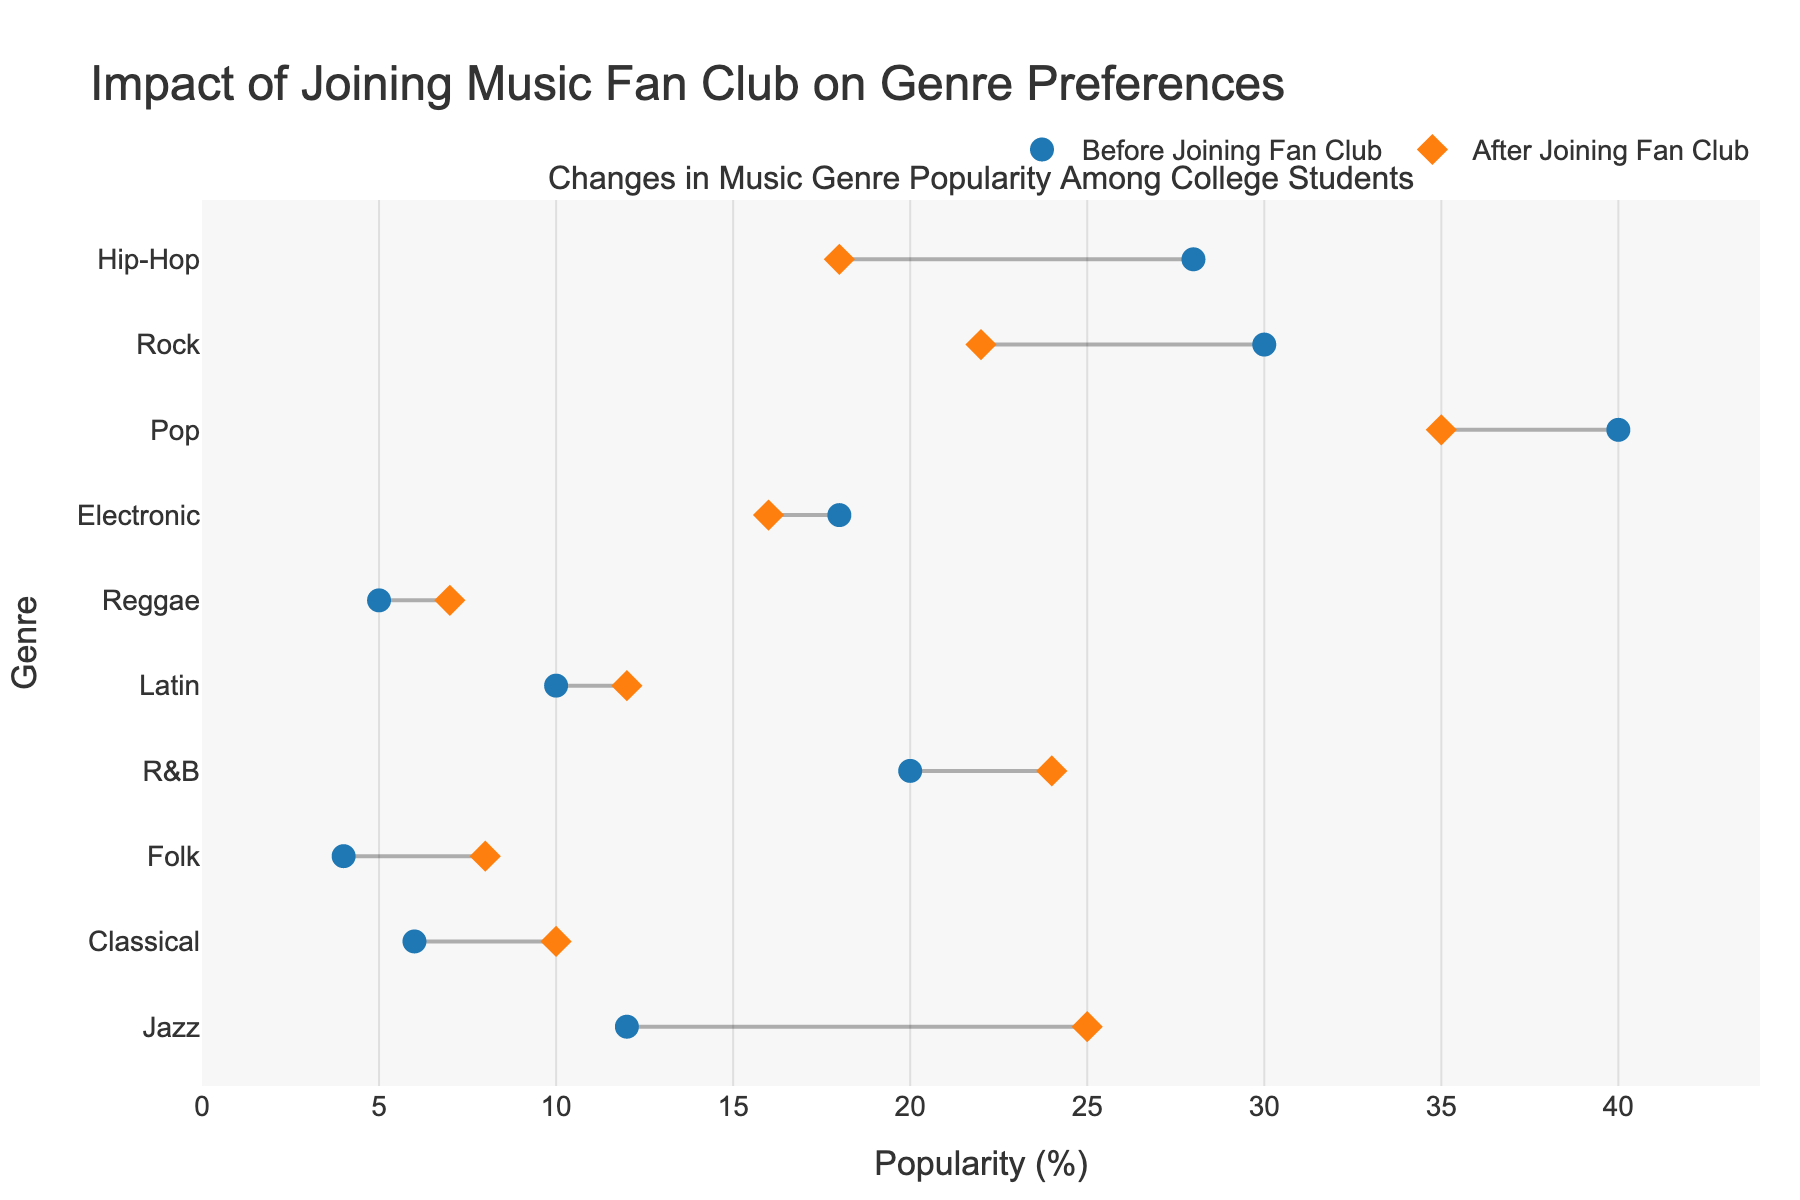What is the title of the figure? The title is clearly displayed at the top of the figure, stating the overall purpose of the plot.
Answer: Impact of Joining Music Fan Club on Genre Preferences What are the colors of the markers for 'Before Joining Fan Club' and 'After Joining Fan Club'? The colors of the markers are visually distinct and are used consistently throughout the plot. The marker for 'Before Joining Fan Club' is blue, and for 'After Joining Fan Club' is orange.
Answer: Blue and Orange Which genre saw the largest increase in popularity after joining the music fan club? The genres are sorted by the difference in popularity, with the largest increase at the top. Jazz has the largest increase, going from 12% to 25%.
Answer: Jazz Which genre saw the largest decrease in popularity after joining the music fan club? By looking at the lengths of the lines, we can identify the largest decrease, which is in Hip-Hop, decreasing from 28% to 18%.
Answer: Hip-Hop What is the overall trend in R&B genre popularity before and after joining the music fan club? The positions of the markers for R&B indicate an increase because the marker for 'After Joining Fan Club' is further right than the marker for 'Before Joining Fan Club’.
Answer: Increase How many genres increased in popularity after joining the fan club? By counting the number of lines where the right marker (After) is further right than the left marker (Before), we can determine the number of genres that increased. There are 6 genres that increased in popularity.
Answer: 6 Compare the popularity change of Classical and Rock genres. Observing both lines, Classical increased from 6% to 10%, a 4 percentage point increase, while Rock decreased from 30% to 22%, an 8 percentage point decrease.
Answer: Classical increased by 4 points, Rock decreased by 8 points What is the combined popularity of Jazz and Folk genres after joining the fan club? To find this, we sum the 'After Joining Fan Club' values for Jazz and Folk. Jazz is 25% and Folk is 8%, so the combined popularity is 25 + 8 = 33%.
Answer: 33% Which genres had no change in popularity? Examining the dumbbell lines, Electronic is the only genre where the before and after markers are at the same position, indicating no change.
Answer: Electronic Calculate the average popularity across all genres after joining the fan club. Sum the 'After Joining Fan Club' values for all genres and divide by the number of genres: (25 + 22 + 35 + 10 + 18 + 16 + 8 + 24 + 12 + 7) / 10 = 177 / 10 = 17.7%.
Answer: 17.7% 